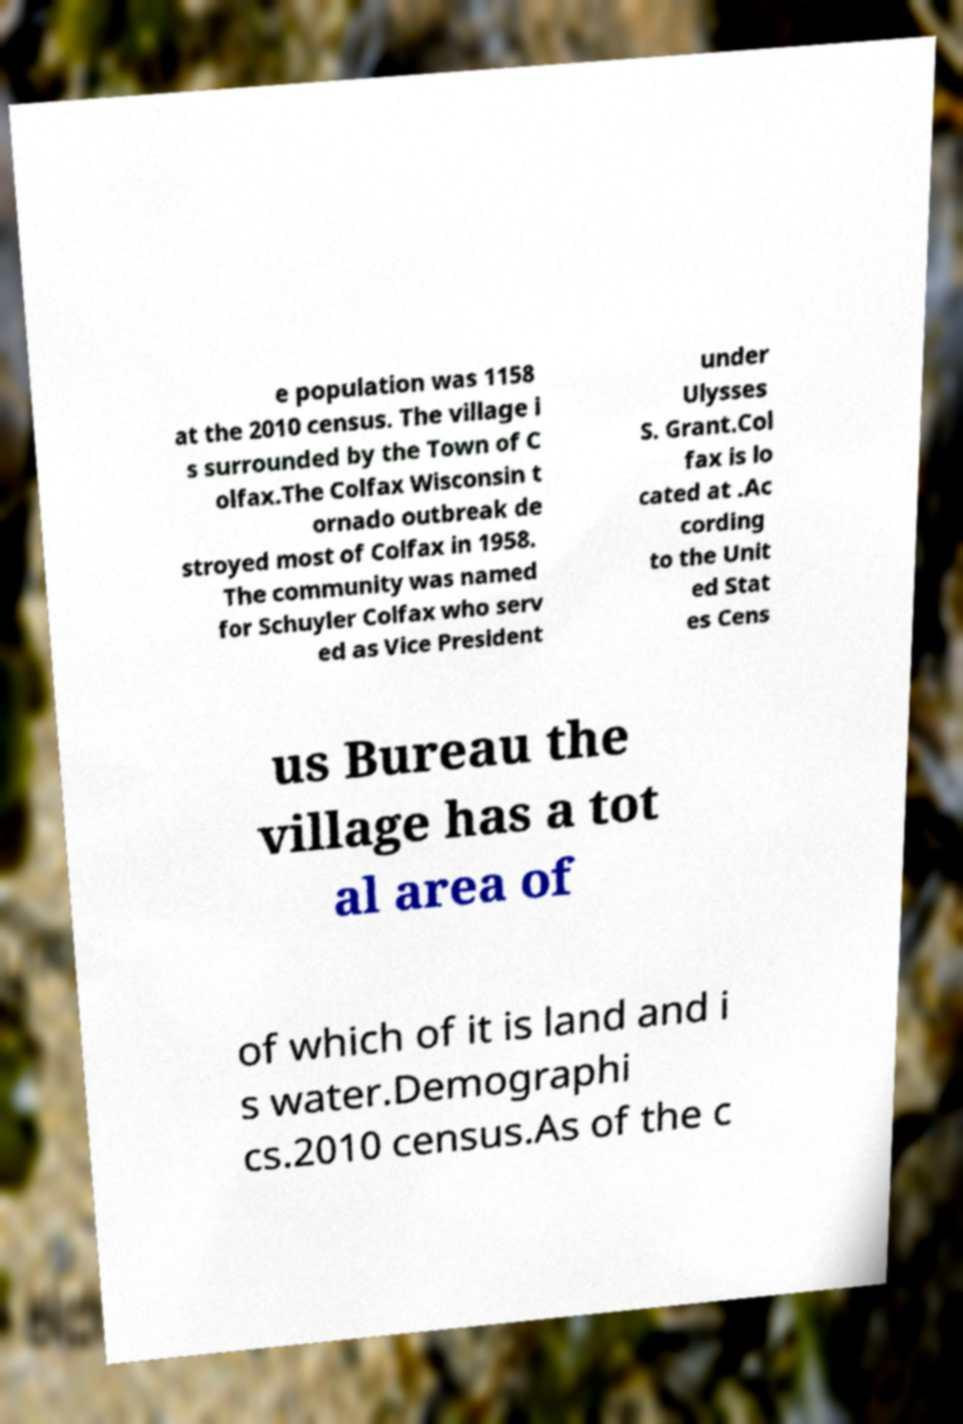Please identify and transcribe the text found in this image. e population was 1158 at the 2010 census. The village i s surrounded by the Town of C olfax.The Colfax Wisconsin t ornado outbreak de stroyed most of Colfax in 1958. The community was named for Schuyler Colfax who serv ed as Vice President under Ulysses S. Grant.Col fax is lo cated at .Ac cording to the Unit ed Stat es Cens us Bureau the village has a tot al area of of which of it is land and i s water.Demographi cs.2010 census.As of the c 